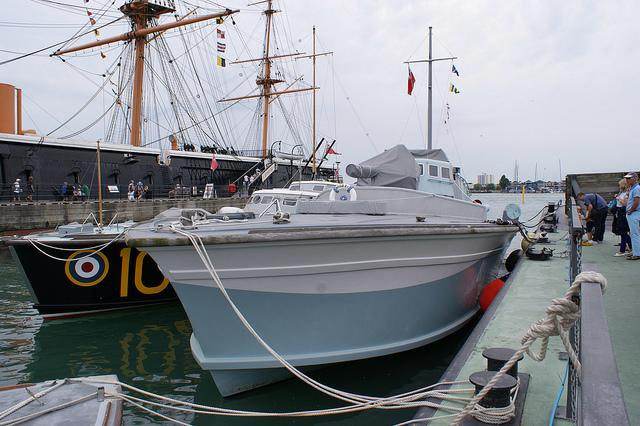What are the people ready to do? Please explain your reasoning. board. They appear to be waiting to a. the other options don't fit. 